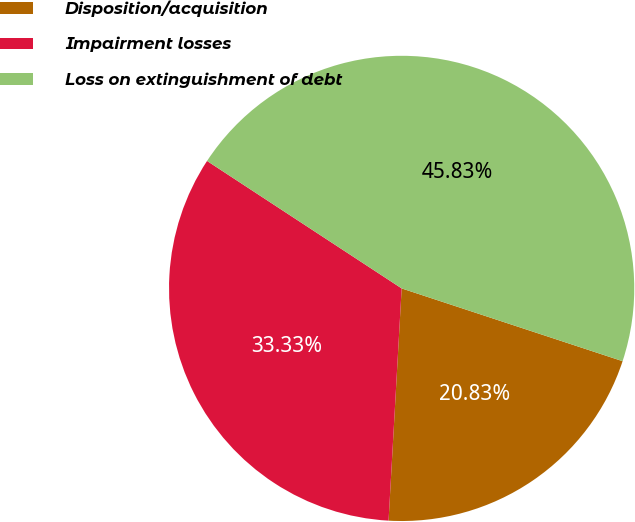<chart> <loc_0><loc_0><loc_500><loc_500><pie_chart><fcel>Disposition/acquisition<fcel>Impairment losses<fcel>Loss on extinguishment of debt<nl><fcel>20.83%<fcel>33.33%<fcel>45.83%<nl></chart> 